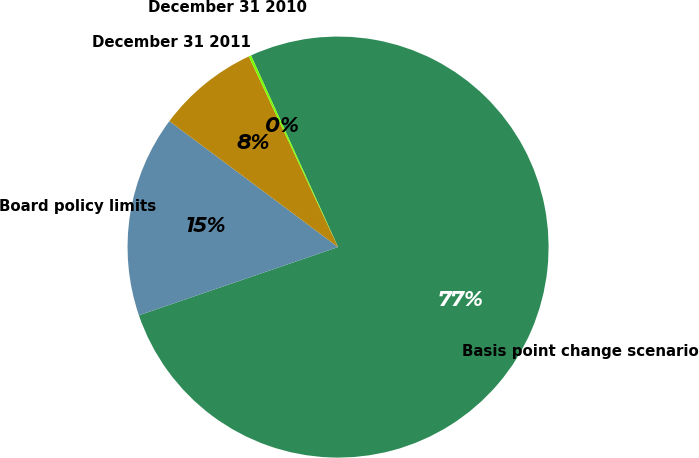<chart> <loc_0><loc_0><loc_500><loc_500><pie_chart><fcel>Basis point change scenario<fcel>Board policy limits<fcel>December 31 2011<fcel>December 31 2010<nl><fcel>76.53%<fcel>15.46%<fcel>7.82%<fcel>0.19%<nl></chart> 